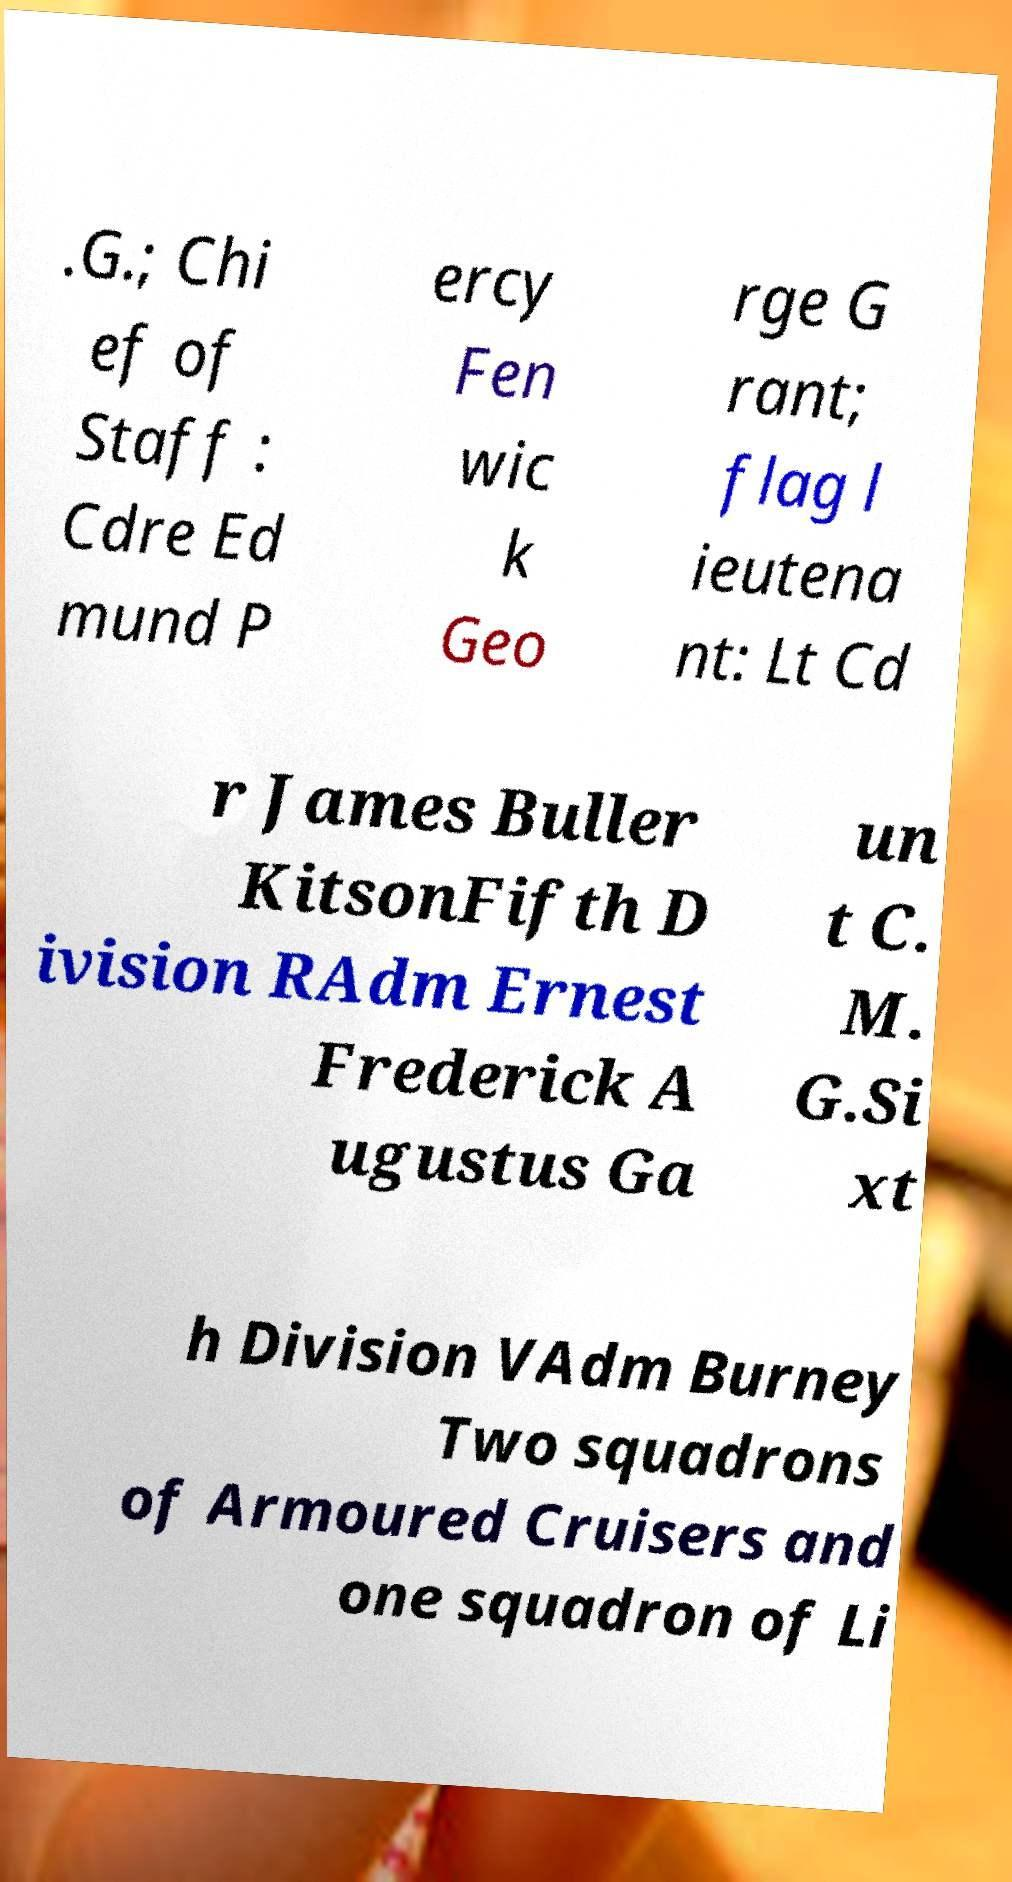Can you accurately transcribe the text from the provided image for me? .G.; Chi ef of Staff : Cdre Ed mund P ercy Fen wic k Geo rge G rant; flag l ieutena nt: Lt Cd r James Buller KitsonFifth D ivision RAdm Ernest Frederick A ugustus Ga un t C. M. G.Si xt h Division VAdm Burney Two squadrons of Armoured Cruisers and one squadron of Li 